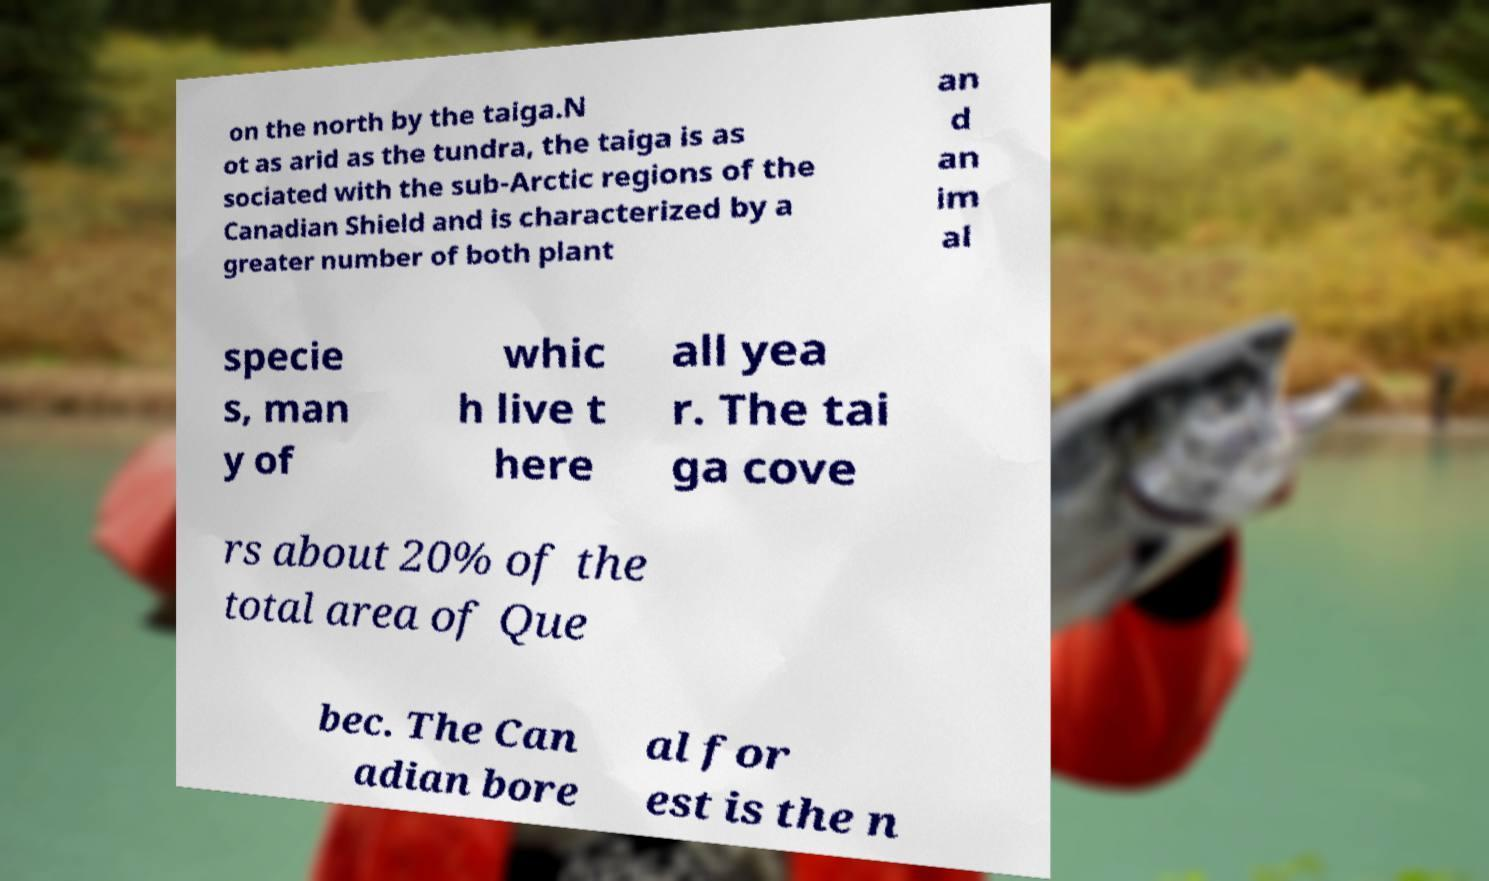I need the written content from this picture converted into text. Can you do that? on the north by the taiga.N ot as arid as the tundra, the taiga is as sociated with the sub-Arctic regions of the Canadian Shield and is characterized by a greater number of both plant an d an im al specie s, man y of whic h live t here all yea r. The tai ga cove rs about 20% of the total area of Que bec. The Can adian bore al for est is the n 